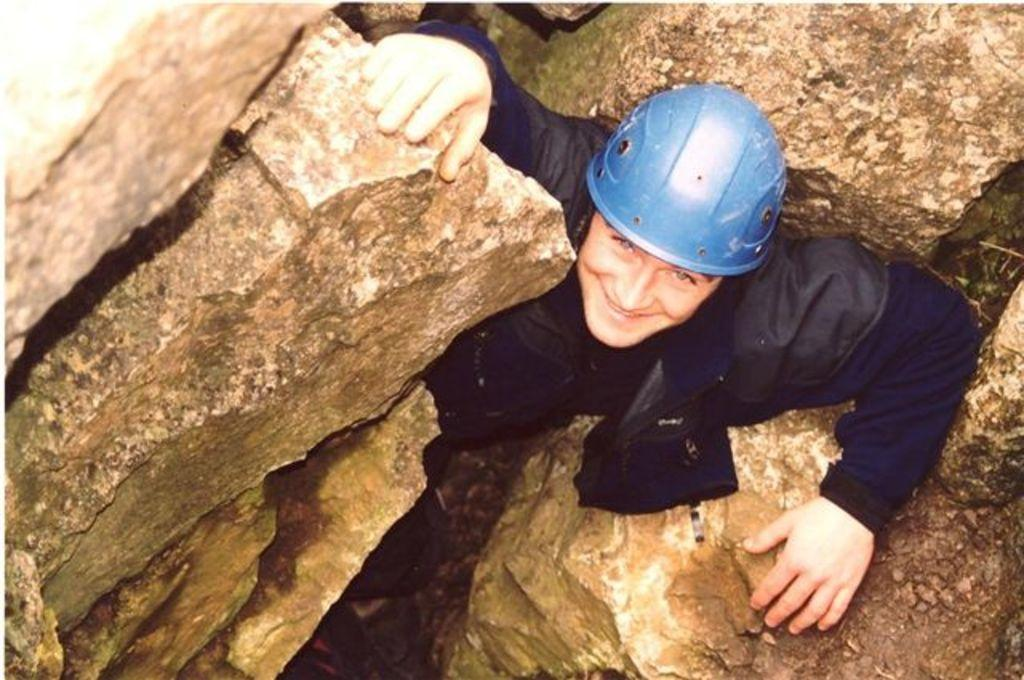What is the main subject of the image? There is a person standing in the image. What is the person wearing on their head? The person is wearing a helmet. What type of landscape can be seen in the image? There are rock hills in the image. What type of flowers can be seen growing on the helmet in the image? There are no flowers present on the helmet in the image. 